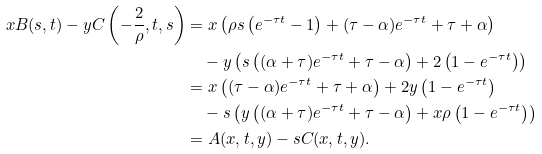<formula> <loc_0><loc_0><loc_500><loc_500>x B ( s , t ) - y C \left ( - \frac { 2 } { \rho } , t , s \right ) & = x \left ( \rho s \left ( e ^ { - \tau t } - 1 \right ) + ( \tau - \alpha ) e ^ { - \tau t } + \tau + \alpha \right ) \\ & \quad - y \left ( s \left ( ( \alpha + \tau ) e ^ { - \tau t } + \tau - \alpha \right ) + 2 \left ( 1 - e ^ { - \tau t } \right ) \right ) \\ & = x \left ( ( \tau - \alpha ) e ^ { - \tau t } + \tau + \alpha \right ) + 2 y \left ( 1 - e ^ { - \tau t } \right ) \\ & \quad - s \left ( y \left ( ( \alpha + \tau ) e ^ { - \tau t } + \tau - \alpha \right ) + x \rho \left ( 1 - e ^ { - \tau t } \right ) \right ) \\ & = A ( x , t , y ) - s C ( x , t , y ) .</formula> 